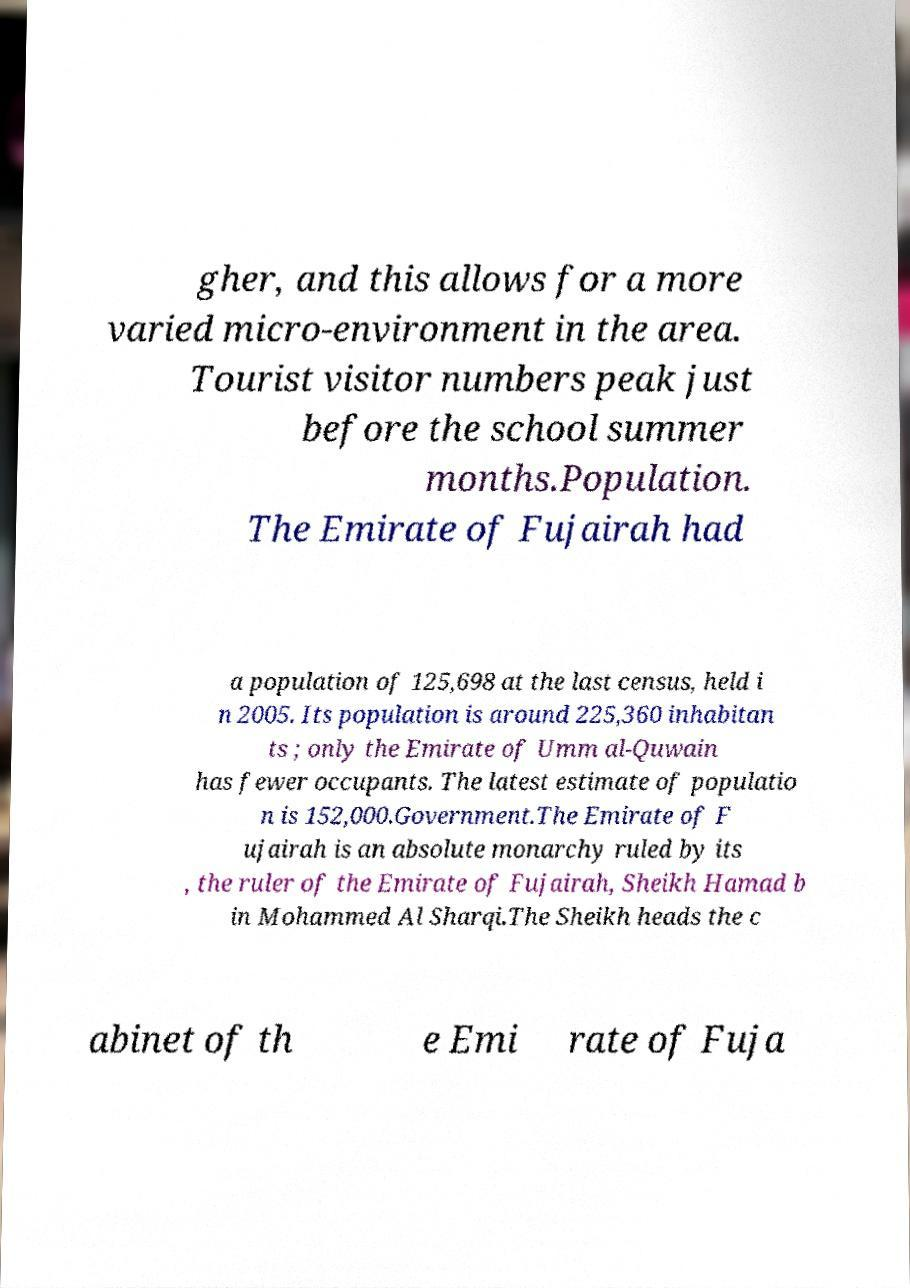What messages or text are displayed in this image? I need them in a readable, typed format. gher, and this allows for a more varied micro-environment in the area. Tourist visitor numbers peak just before the school summer months.Population. The Emirate of Fujairah had a population of 125,698 at the last census, held i n 2005. Its population is around 225,360 inhabitan ts ; only the Emirate of Umm al-Quwain has fewer occupants. The latest estimate of populatio n is 152,000.Government.The Emirate of F ujairah is an absolute monarchy ruled by its , the ruler of the Emirate of Fujairah, Sheikh Hamad b in Mohammed Al Sharqi.The Sheikh heads the c abinet of th e Emi rate of Fuja 